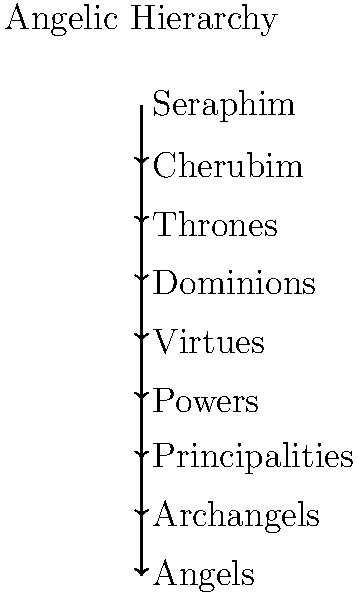In Christian angelology, which order of angels is directly above the Archangels in the celestial hierarchy? To answer this question, we need to understand the traditional Christian angelic hierarchy, often referred to as the "Nine Choirs of Angels." This hierarchy is based on the writings of Pseudo-Dionysius the Areopagite and is widely accepted in many Christian traditions. The hierarchy, from highest to lowest, is as follows:

1. Seraphim
2. Cherubim
3. Thrones
4. Dominions
5. Virtues
6. Powers
7. Principalities
8. Archangels
9. Angels

In this hierarchy, each level is believed to have specific roles and responsibilities in serving God and humanity. The question asks about the order directly above the Archangels, which we can see from the list is the Principalities.

Principalities are believed to be responsible for overseeing groups of people. They are thought to inspire living things to many things such as art or science. 

Archangels, the level below Principalities, are considered God's messengers to humans. They are often depicted in religious art and literature as the most recognizable angels, with Michael, Gabriel, and Raphael being among the most well-known.

Therefore, the order of angels directly above Archangels in the celestial hierarchy is the Principalities.
Answer: Principalities 